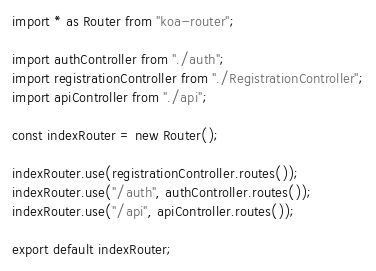Convert code to text. <code><loc_0><loc_0><loc_500><loc_500><_TypeScript_>import * as Router from "koa-router";

import authController from "./auth";
import registrationController from "./RegistrationController";
import apiController from "./api";

const indexRouter = new Router();

indexRouter.use(registrationController.routes());
indexRouter.use("/auth", authController.routes());
indexRouter.use("/api", apiController.routes());

export default indexRouter;
</code> 